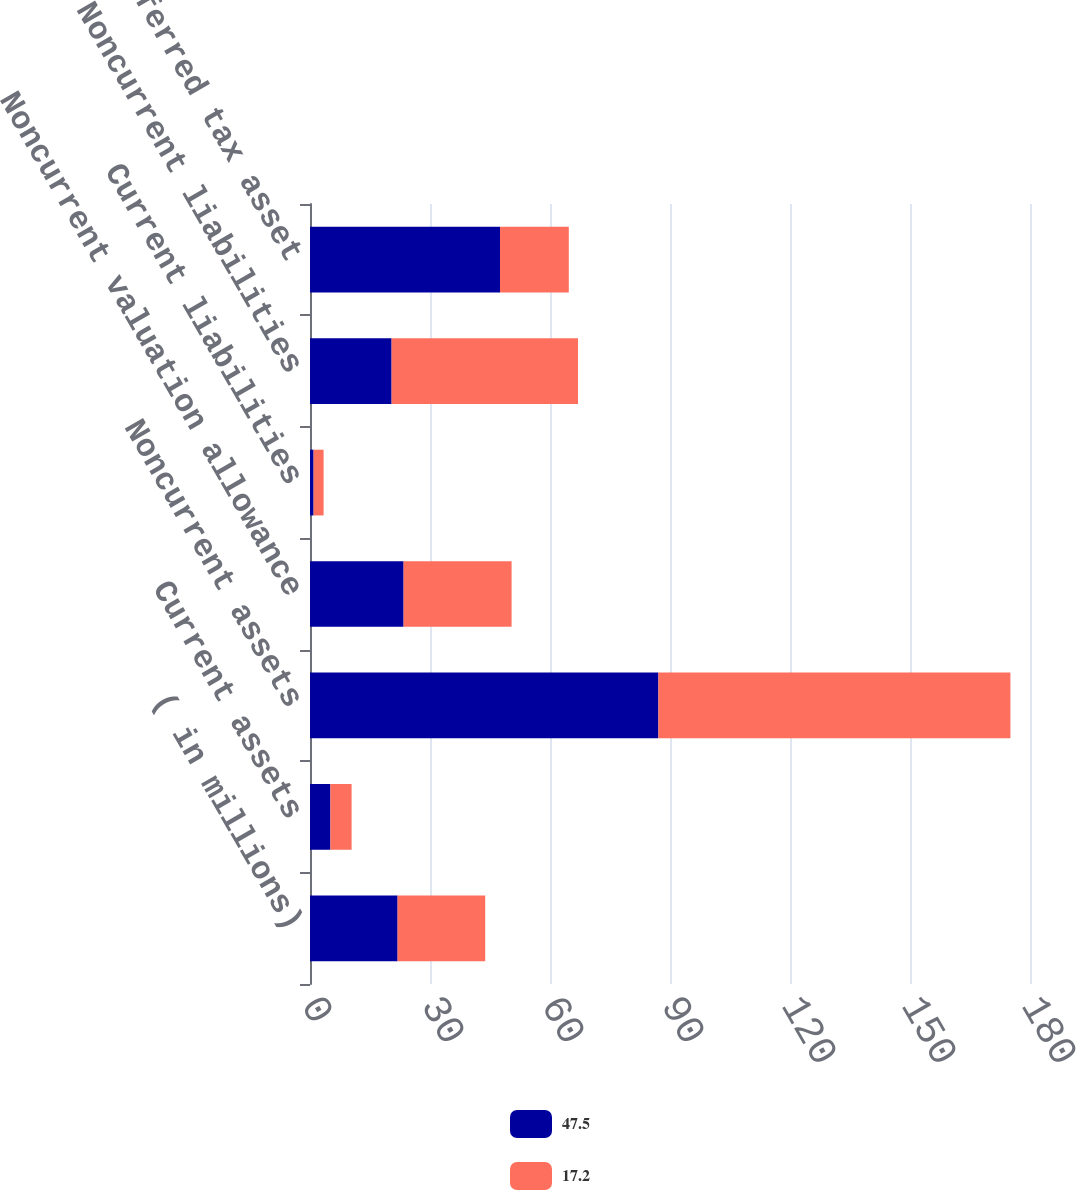Convert chart. <chart><loc_0><loc_0><loc_500><loc_500><stacked_bar_chart><ecel><fcel>( in millions)<fcel>Current assets<fcel>Noncurrent assets<fcel>Noncurrent valuation allowance<fcel>Current liabilities<fcel>Noncurrent liabilities<fcel>Deferred tax asset<nl><fcel>47.5<fcel>21.9<fcel>5.1<fcel>87.1<fcel>23.4<fcel>0.9<fcel>20.4<fcel>47.5<nl><fcel>17.2<fcel>21.9<fcel>5.3<fcel>88<fcel>27<fcel>2.5<fcel>46.6<fcel>17.2<nl></chart> 